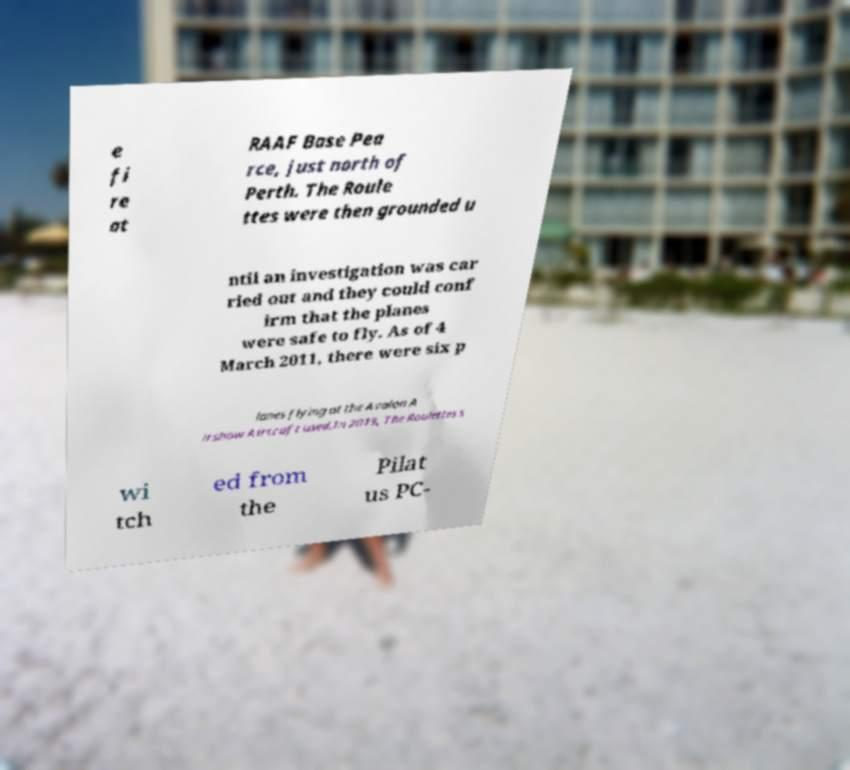What messages or text are displayed in this image? I need them in a readable, typed format. e fi re at RAAF Base Pea rce, just north of Perth. The Roule ttes were then grounded u ntil an investigation was car ried out and they could conf irm that the planes were safe to fly. As of 4 March 2011, there were six p lanes flying at the Avalon A irshow.Aircraft used.In 2019, The Roulettes s wi tch ed from the Pilat us PC- 